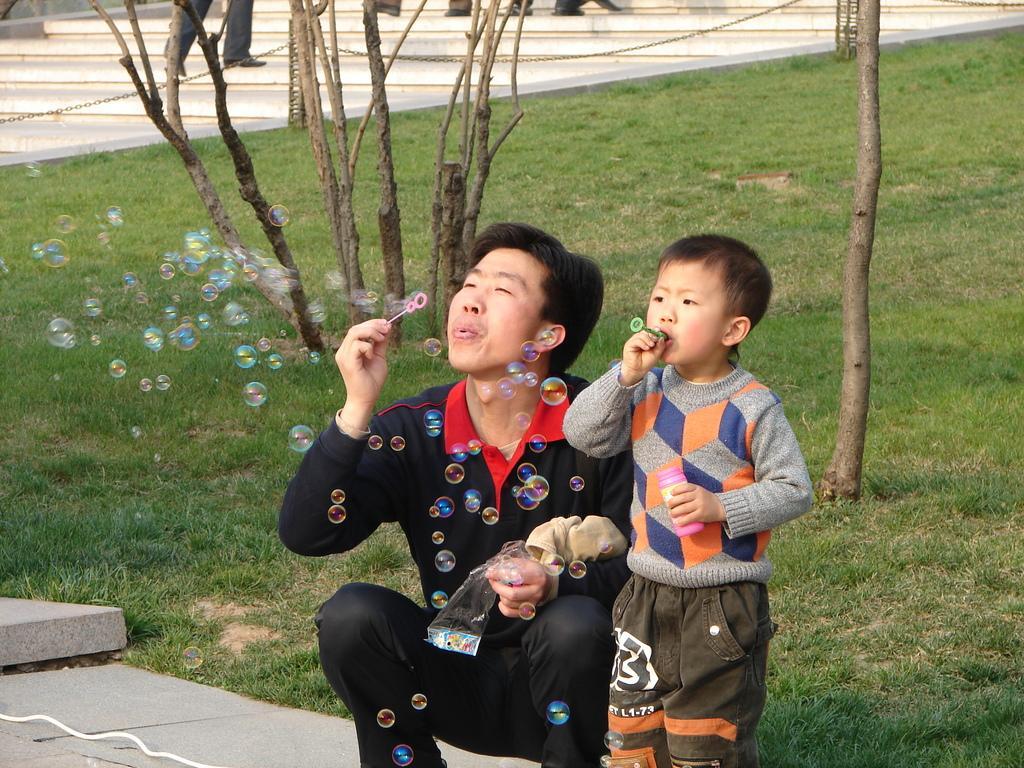Please provide a concise description of this image. In this image we can see a a man and a boy and they both are blowing bubbles and we can see few tree trunks and grass on the ground. We can see few persons legs in the background. 